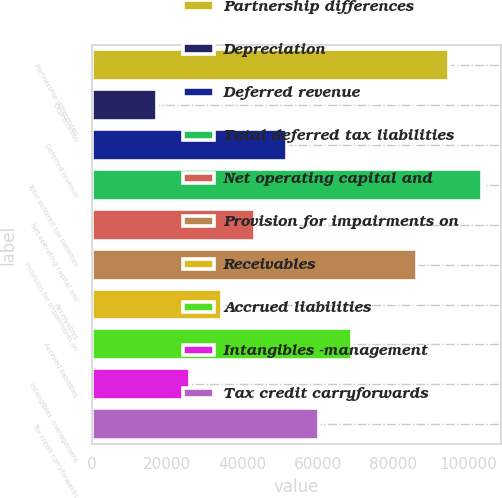Convert chart to OTSL. <chart><loc_0><loc_0><loc_500><loc_500><bar_chart><fcel>Partnership differences<fcel>Depreciation<fcel>Deferred revenue<fcel>Total deferred tax liabilities<fcel>Net operating capital and<fcel>Provision for impairments on<fcel>Receivables<fcel>Accrued liabilities<fcel>Intangibles -management<fcel>Tax credit carryforwards<nl><fcel>94811.1<fcel>17365.2<fcel>51785.6<fcel>103416<fcel>43180.5<fcel>86206<fcel>34575.4<fcel>68995.8<fcel>25970.3<fcel>60390.7<nl></chart> 